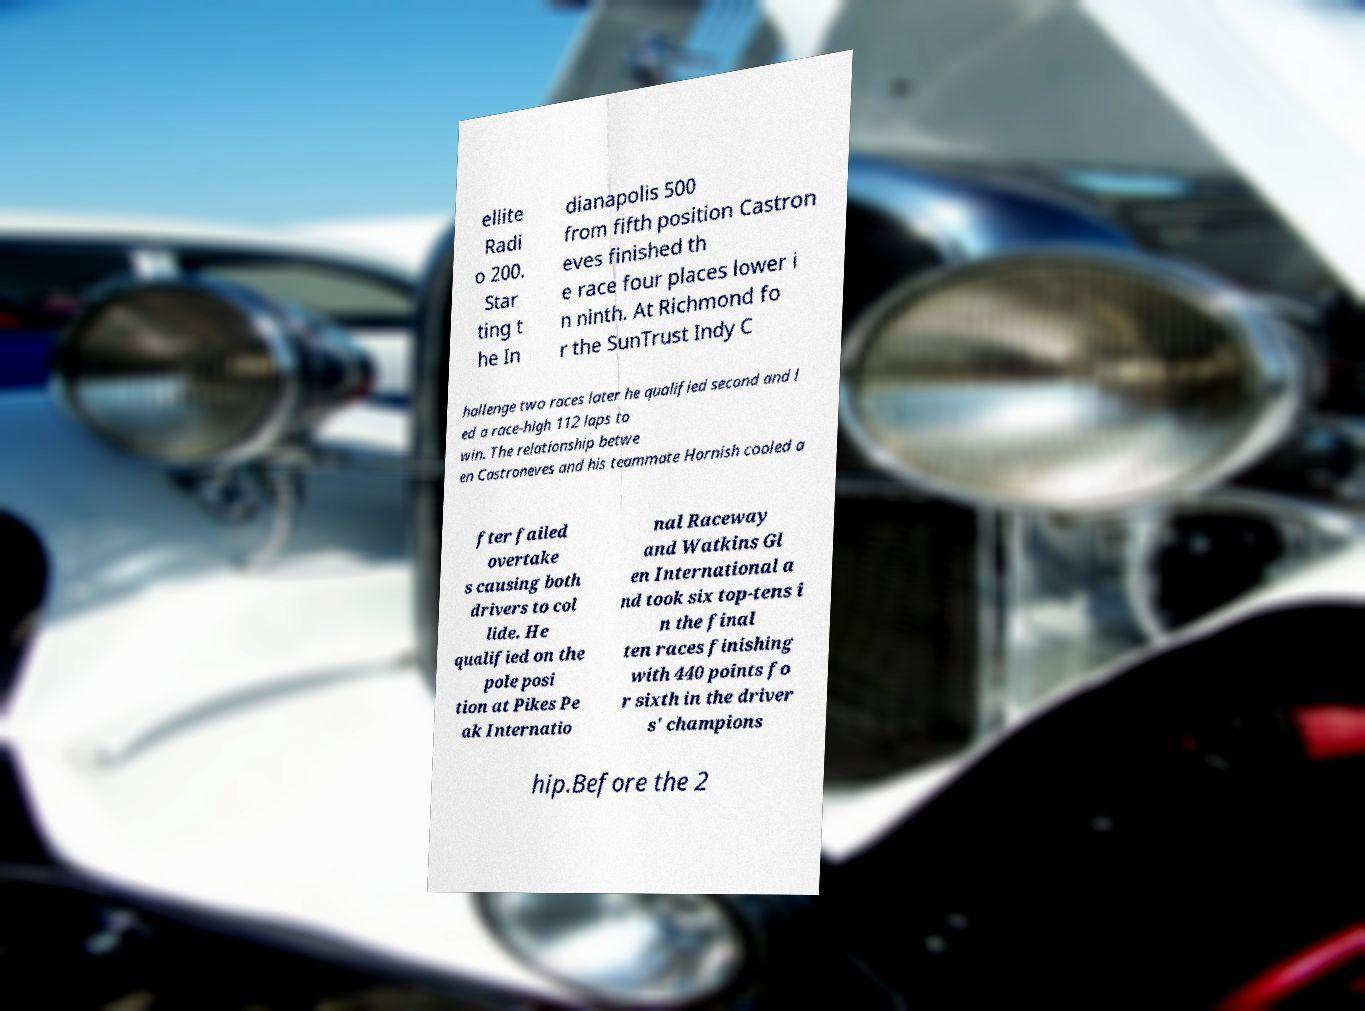Can you read and provide the text displayed in the image?This photo seems to have some interesting text. Can you extract and type it out for me? ellite Radi o 200. Star ting t he In dianapolis 500 from fifth position Castron eves finished th e race four places lower i n ninth. At Richmond fo r the SunTrust Indy C hallenge two races later he qualified second and l ed a race-high 112 laps to win. The relationship betwe en Castroneves and his teammate Hornish cooled a fter failed overtake s causing both drivers to col lide. He qualified on the pole posi tion at Pikes Pe ak Internatio nal Raceway and Watkins Gl en International a nd took six top-tens i n the final ten races finishing with 440 points fo r sixth in the driver s' champions hip.Before the 2 